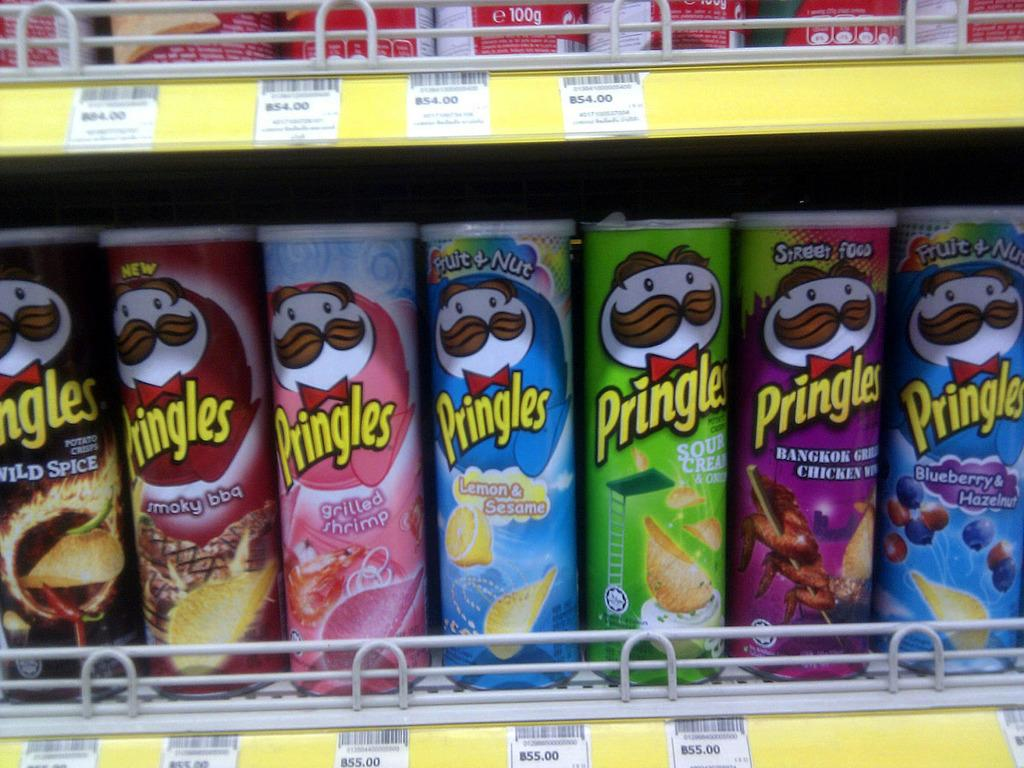<image>
Create a compact narrative representing the image presented. A row of Pringles chip cans on a grocery store shelf. 